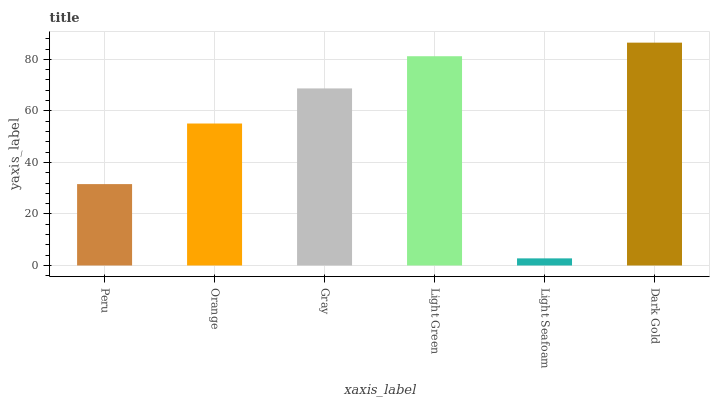Is Light Seafoam the minimum?
Answer yes or no. Yes. Is Dark Gold the maximum?
Answer yes or no. Yes. Is Orange the minimum?
Answer yes or no. No. Is Orange the maximum?
Answer yes or no. No. Is Orange greater than Peru?
Answer yes or no. Yes. Is Peru less than Orange?
Answer yes or no. Yes. Is Peru greater than Orange?
Answer yes or no. No. Is Orange less than Peru?
Answer yes or no. No. Is Gray the high median?
Answer yes or no. Yes. Is Orange the low median?
Answer yes or no. Yes. Is Light Green the high median?
Answer yes or no. No. Is Peru the low median?
Answer yes or no. No. 